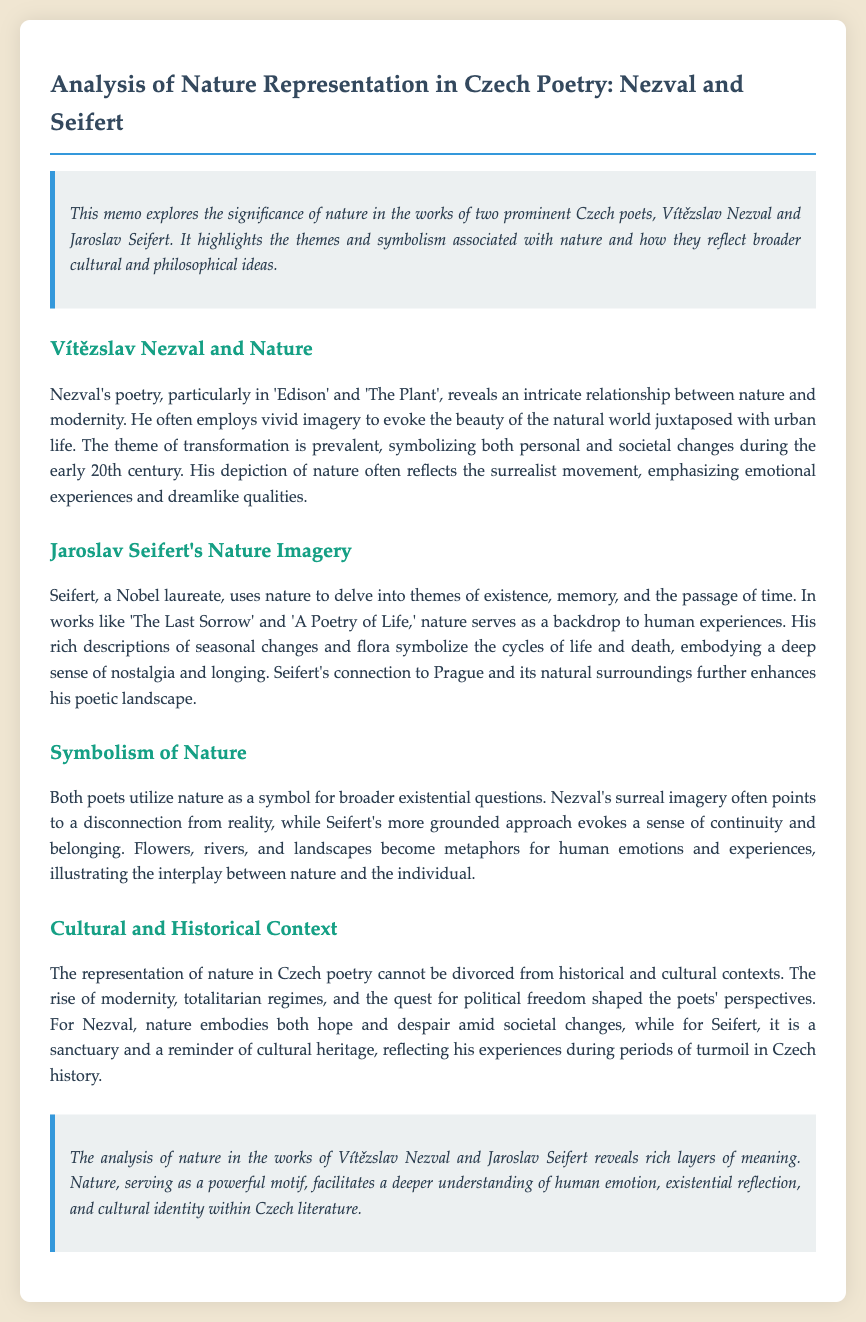What two poets are analyzed in the document? The document focuses on the works of Vítězslav Nezval and Jaroslav Seifert.
Answer: Vítězslav Nezval and Jaroslav Seifert What is one theme prevalent in Nezval's poetry? The theme of transformation is prevalent in Nezval's works, symbolizing personal and societal changes.
Answer: Transformation Which Nobel laureate is discussed in the memo? The memo mentions Jaroslav Seifert as a Nobel laureate noted for his poetry.
Answer: Jaroslav Seifert What literary movement is Nezval associated with? Nezval's poetry reflects the surrealist movement, emphasizing emotional experiences and dreamlike qualities.
Answer: Surrealist movement In Seifert's works, what do seasonal changes symbolize? In Seifert's poetry, seasonal changes symbolize the cycles of life and death, embodying nostalgia and longing.
Answer: Cycles of life and death What cultural aspect shapes the poets' perspectives on nature? The representation of nature is influenced by the rise of modernity and totalitarian regimes in Czech history.
Answer: Historical and cultural contexts What do flowers, rivers, and landscapes represent in the poetry? Flowers, rivers, and landscapes serve as metaphors for human emotions and experiences in the works of both poets.
Answer: Human emotions and experiences What is the overall significance of nature in the analysis? The significance of nature in Nezval and Seifert's works lies in its ability to deepen understanding of human emotion, existential reflection, and cultural identity.
Answer: Deeper understanding of human emotion What type of poem does Nezval's work "The Plant" represent? "The Plant" is one of Nezval's works that represent the intricate relationship between nature and modernity.
Answer: Poem represent modernity 